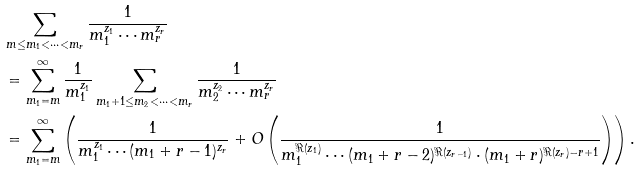<formula> <loc_0><loc_0><loc_500><loc_500>& \sum _ { m \leq m _ { 1 } < \cdots < m _ { r } } \frac { 1 } { m _ { 1 } ^ { z _ { 1 } } \cdots m _ { r } ^ { z _ { r } } } \\ & = \sum _ { m _ { 1 } = m } ^ { \infty } \frac { 1 } { m _ { 1 } ^ { z _ { 1 } } } \sum _ { m _ { 1 } + 1 \leq m _ { 2 } < \cdots < m _ { r } } \frac { 1 } { m _ { 2 } ^ { z _ { 2 } } \cdots m _ { r } ^ { z _ { r } } } \\ & = \sum _ { m _ { 1 } = m } ^ { \infty } \left ( \frac { 1 } { m _ { 1 } ^ { z _ { 1 } } \cdots ( m _ { 1 } + r - 1 ) ^ { z _ { r } } } + O \left ( \frac { 1 } { m _ { 1 } ^ { \Re ( z _ { 1 } ) } \cdots ( m _ { 1 } + r - 2 ) ^ { \Re ( z _ { r - 1 } ) } \cdot ( m _ { 1 } + r ) ^ { \Re ( z _ { r } ) - r + 1 } } \right ) \right ) .</formula> 